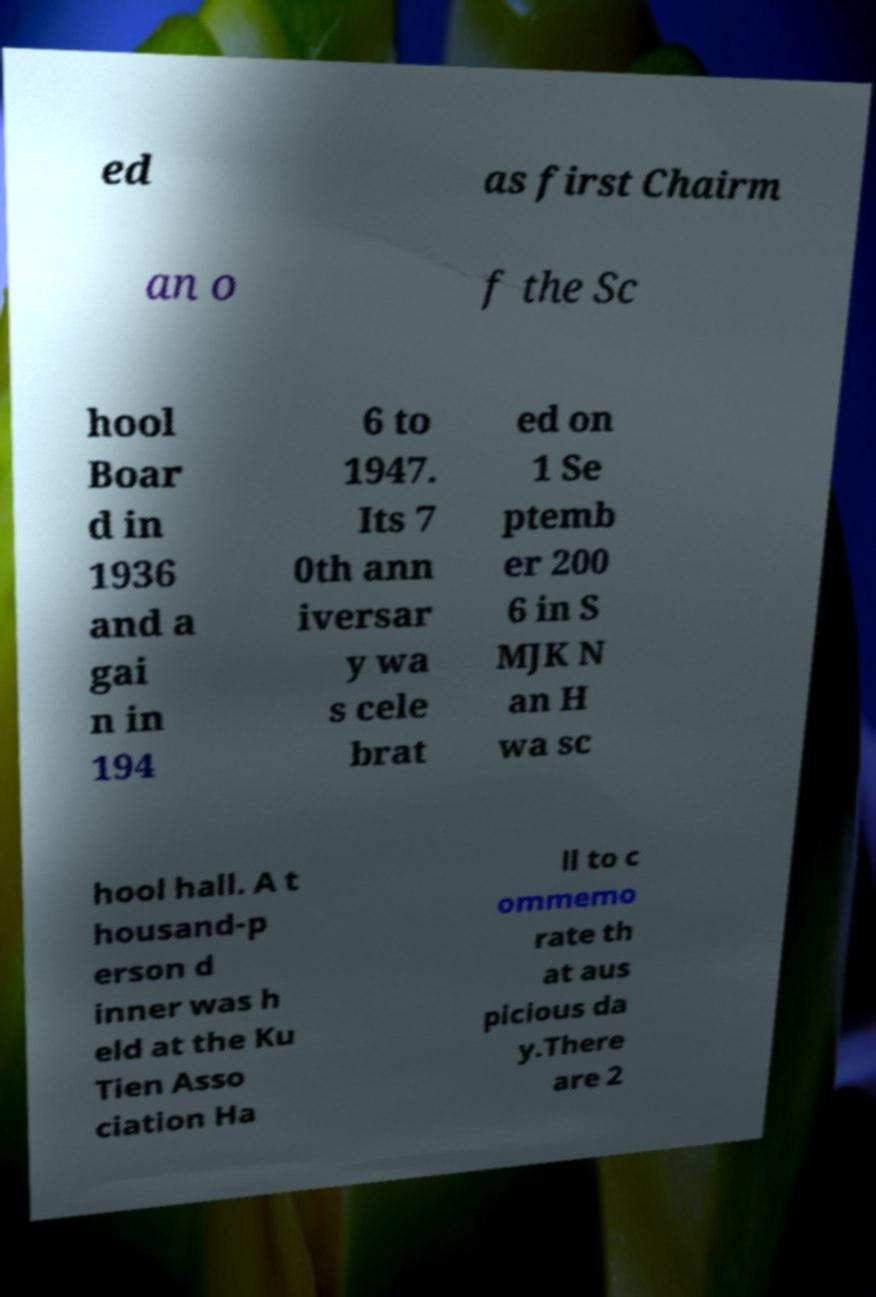Can you accurately transcribe the text from the provided image for me? ed as first Chairm an o f the Sc hool Boar d in 1936 and a gai n in 194 6 to 1947. Its 7 0th ann iversar y wa s cele brat ed on 1 Se ptemb er 200 6 in S MJK N an H wa sc hool hall. A t housand-p erson d inner was h eld at the Ku Tien Asso ciation Ha ll to c ommemo rate th at aus picious da y.There are 2 